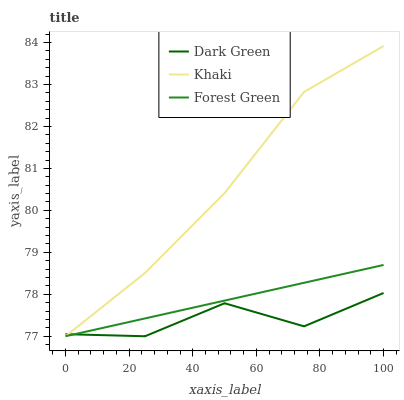Does Dark Green have the minimum area under the curve?
Answer yes or no. Yes. Does Khaki have the maximum area under the curve?
Answer yes or no. Yes. Does Khaki have the minimum area under the curve?
Answer yes or no. No. Does Dark Green have the maximum area under the curve?
Answer yes or no. No. Is Forest Green the smoothest?
Answer yes or no. Yes. Is Dark Green the roughest?
Answer yes or no. Yes. Is Khaki the smoothest?
Answer yes or no. No. Is Khaki the roughest?
Answer yes or no. No. Does Forest Green have the lowest value?
Answer yes or no. Yes. Does Khaki have the highest value?
Answer yes or no. Yes. Does Dark Green have the highest value?
Answer yes or no. No. Does Dark Green intersect Forest Green?
Answer yes or no. Yes. Is Dark Green less than Forest Green?
Answer yes or no. No. Is Dark Green greater than Forest Green?
Answer yes or no. No. 